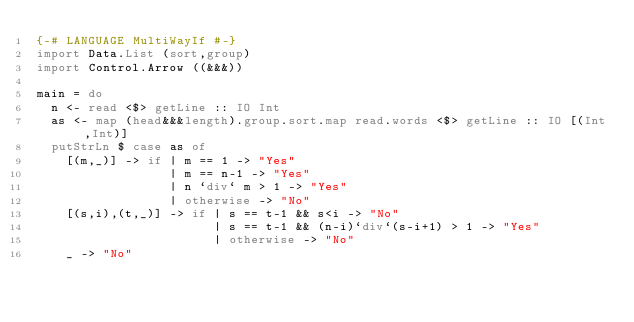<code> <loc_0><loc_0><loc_500><loc_500><_Haskell_>{-# LANGUAGE MultiWayIf #-}
import Data.List (sort,group)
import Control.Arrow ((&&&))

main = do
  n <- read <$> getLine :: IO Int
  as <- map (head&&&length).group.sort.map read.words <$> getLine :: IO [(Int,Int)]
  putStrLn $ case as of
    [(m,_)] -> if | m == 1 -> "Yes"
                  | m == n-1 -> "Yes"
                  | n `div` m > 1 -> "Yes"
                  | otherwise -> "No"
    [(s,i),(t,_)] -> if | s == t-1 && s<i -> "No"
                        | s == t-1 && (n-i)`div`(s-i+1) > 1 -> "Yes"
                        | otherwise -> "No"
    _ -> "No"
</code> 